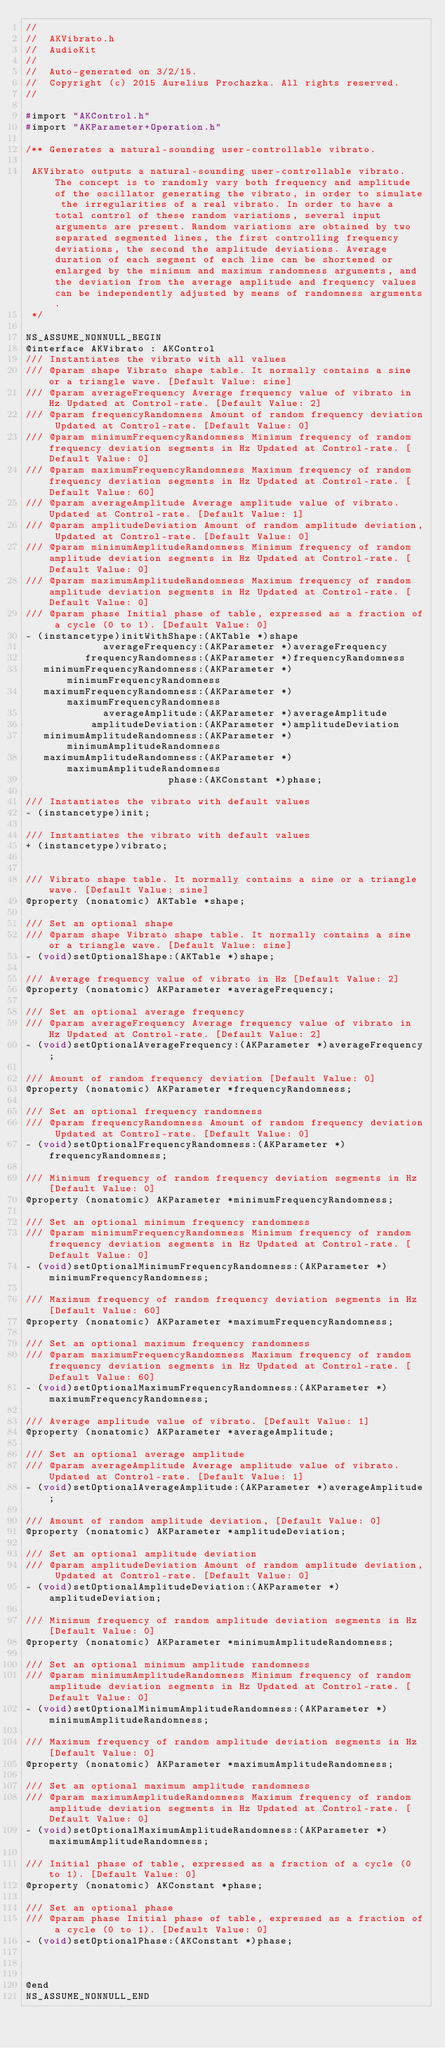Convert code to text. <code><loc_0><loc_0><loc_500><loc_500><_C_>//
//  AKVibrato.h
//  AudioKit
//
//  Auto-generated on 3/2/15.
//  Copyright (c) 2015 Aurelius Prochazka. All rights reserved.
//

#import "AKControl.h"
#import "AKParameter+Operation.h"

/** Generates a natural-sounding user-controllable vibrato.

 AKVibrato outputs a natural-sounding user-controllable vibrato. The concept is to randomly vary both frequency and amplitude of the oscillator generating the vibrato, in order to simulate the irregularities of a real vibrato. In order to have a total control of these random variations, several input arguments are present. Random variations are obtained by two separated segmented lines, the first controlling frequency deviations, the second the amplitude deviations. Average duration of each segment of each line can be shortened or enlarged by the minimum and maximum randomness arguments, and the deviation from the average amplitude and frequency values can be independently adjusted by means of randomness arguments.
 */

NS_ASSUME_NONNULL_BEGIN
@interface AKVibrato : AKControl
/// Instantiates the vibrato with all values
/// @param shape Vibrato shape table. It normally contains a sine or a triangle wave. [Default Value: sine]
/// @param averageFrequency Average frequency value of vibrato in Hz Updated at Control-rate. [Default Value: 2]
/// @param frequencyRandomness Amount of random frequency deviation Updated at Control-rate. [Default Value: 0]
/// @param minimumFrequencyRandomness Minimum frequency of random frequency deviation segments in Hz Updated at Control-rate. [Default Value: 0]
/// @param maximumFrequencyRandomness Maximum frequency of random frequency deviation segments in Hz Updated at Control-rate. [Default Value: 60]
/// @param averageAmplitude Average amplitude value of vibrato. Updated at Control-rate. [Default Value: 1]
/// @param amplitudeDeviation Amount of random amplitude deviation, Updated at Control-rate. [Default Value: 0]
/// @param minimumAmplitudeRandomness Minimum frequency of random amplitude deviation segments in Hz Updated at Control-rate. [Default Value: 0]
/// @param maximumAmplitudeRandomness Maximum frequency of random amplitude deviation segments in Hz Updated at Control-rate. [Default Value: 0]
/// @param phase Initial phase of table, expressed as a fraction of a cycle (0 to 1). [Default Value: 0]
- (instancetype)initWithShape:(AKTable *)shape
             averageFrequency:(AKParameter *)averageFrequency
          frequencyRandomness:(AKParameter *)frequencyRandomness
   minimumFrequencyRandomness:(AKParameter *)minimumFrequencyRandomness
   maximumFrequencyRandomness:(AKParameter *)maximumFrequencyRandomness
             averageAmplitude:(AKParameter *)averageAmplitude
           amplitudeDeviation:(AKParameter *)amplitudeDeviation
   minimumAmplitudeRandomness:(AKParameter *)minimumAmplitudeRandomness
   maximumAmplitudeRandomness:(AKParameter *)maximumAmplitudeRandomness
                        phase:(AKConstant *)phase;

/// Instantiates the vibrato with default values
- (instancetype)init;

/// Instantiates the vibrato with default values
+ (instancetype)vibrato;


/// Vibrato shape table. It normally contains a sine or a triangle wave. [Default Value: sine]
@property (nonatomic) AKTable *shape;

/// Set an optional shape
/// @param shape Vibrato shape table. It normally contains a sine or a triangle wave. [Default Value: sine]
- (void)setOptionalShape:(AKTable *)shape;

/// Average frequency value of vibrato in Hz [Default Value: 2]
@property (nonatomic) AKParameter *averageFrequency;

/// Set an optional average frequency
/// @param averageFrequency Average frequency value of vibrato in Hz Updated at Control-rate. [Default Value: 2]
- (void)setOptionalAverageFrequency:(AKParameter *)averageFrequency;

/// Amount of random frequency deviation [Default Value: 0]
@property (nonatomic) AKParameter *frequencyRandomness;

/// Set an optional frequency randomness
/// @param frequencyRandomness Amount of random frequency deviation Updated at Control-rate. [Default Value: 0]
- (void)setOptionalFrequencyRandomness:(AKParameter *)frequencyRandomness;

/// Minimum frequency of random frequency deviation segments in Hz [Default Value: 0]
@property (nonatomic) AKParameter *minimumFrequencyRandomness;

/// Set an optional minimum frequency randomness
/// @param minimumFrequencyRandomness Minimum frequency of random frequency deviation segments in Hz Updated at Control-rate. [Default Value: 0]
- (void)setOptionalMinimumFrequencyRandomness:(AKParameter *)minimumFrequencyRandomness;

/// Maximum frequency of random frequency deviation segments in Hz [Default Value: 60]
@property (nonatomic) AKParameter *maximumFrequencyRandomness;

/// Set an optional maximum frequency randomness
/// @param maximumFrequencyRandomness Maximum frequency of random frequency deviation segments in Hz Updated at Control-rate. [Default Value: 60]
- (void)setOptionalMaximumFrequencyRandomness:(AKParameter *)maximumFrequencyRandomness;

/// Average amplitude value of vibrato. [Default Value: 1]
@property (nonatomic) AKParameter *averageAmplitude;

/// Set an optional average amplitude
/// @param averageAmplitude Average amplitude value of vibrato. Updated at Control-rate. [Default Value: 1]
- (void)setOptionalAverageAmplitude:(AKParameter *)averageAmplitude;

/// Amount of random amplitude deviation, [Default Value: 0]
@property (nonatomic) AKParameter *amplitudeDeviation;

/// Set an optional amplitude deviation
/// @param amplitudeDeviation Amount of random amplitude deviation, Updated at Control-rate. [Default Value: 0]
- (void)setOptionalAmplitudeDeviation:(AKParameter *)amplitudeDeviation;

/// Minimum frequency of random amplitude deviation segments in Hz [Default Value: 0]
@property (nonatomic) AKParameter *minimumAmplitudeRandomness;

/// Set an optional minimum amplitude randomness
/// @param minimumAmplitudeRandomness Minimum frequency of random amplitude deviation segments in Hz Updated at Control-rate. [Default Value: 0]
- (void)setOptionalMinimumAmplitudeRandomness:(AKParameter *)minimumAmplitudeRandomness;

/// Maximum frequency of random amplitude deviation segments in Hz [Default Value: 0]
@property (nonatomic) AKParameter *maximumAmplitudeRandomness;

/// Set an optional maximum amplitude randomness
/// @param maximumAmplitudeRandomness Maximum frequency of random amplitude deviation segments in Hz Updated at Control-rate. [Default Value: 0]
- (void)setOptionalMaximumAmplitudeRandomness:(AKParameter *)maximumAmplitudeRandomness;

/// Initial phase of table, expressed as a fraction of a cycle (0 to 1). [Default Value: 0]
@property (nonatomic) AKConstant *phase;

/// Set an optional phase
/// @param phase Initial phase of table, expressed as a fraction of a cycle (0 to 1). [Default Value: 0]
- (void)setOptionalPhase:(AKConstant *)phase;



@end
NS_ASSUME_NONNULL_END
</code> 